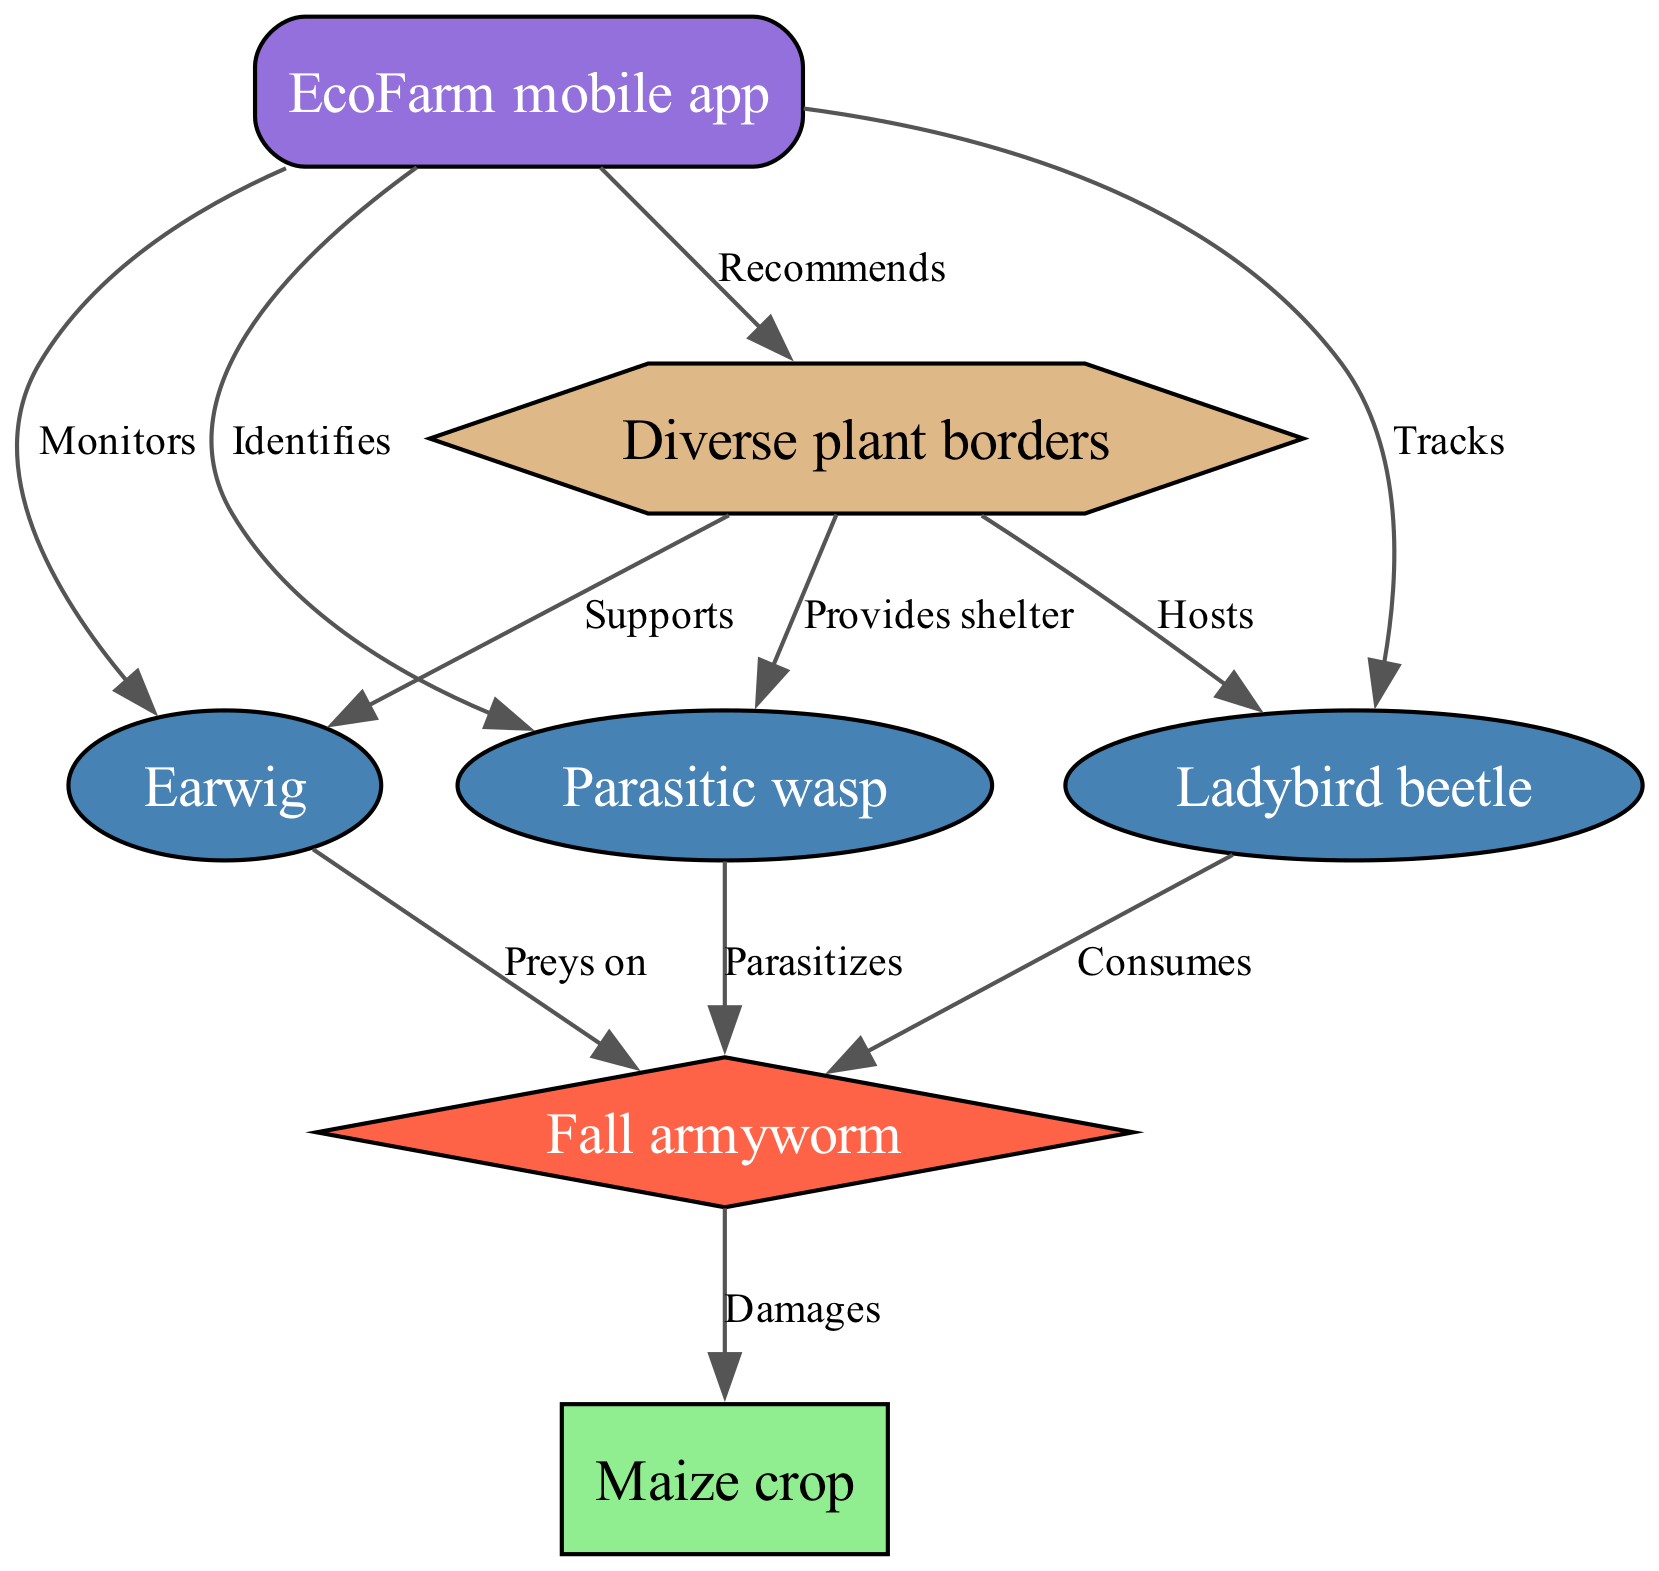What is the main crop shown in the diagram? The diagram specifically labels the main crop as "Maize crop." This information is presented in the nodes section, where each node has its unique label, and the crop is clearly marked.
Answer: Maize crop How many predators are represented in the diagram? By counting the nodes labeled as predators, we see "Earwig," "Ladybird beetle," and "Parasitic wasp," which totals to three distinct predators.
Answer: 3 What does the Earwig do to the Fall armyworm? The connection between "Earwig" and "Fall armyworm" is indicated with the label "Preys on," showing a direct predatory relationship from the Earwig towards the pest.
Answer: Preys on Which predator is supported by the Diverse plant borders? Looking at the edges connected to "Diverse plant borders," it is evident that "Earwig" is directly linked and noted with the label "Supports," indicating its reliance on this habitat.
Answer: Earwig What is the role of the EcoFarm mobile app in the ecosystem? The app establishes various connections with the predators, such as monitoring, tracking, and identifying them. This shows that its role is primarily focused on managing these predators in the agricultural ecosystem.
Answer: Manages predators Which organism does the Parasitic wasp affect? The diagram directly shows an arrow from "Parasitic wasp" to "Fall armyworm" with the label "Parasitizes." This indicates that the Parasitic wasp is aimed at affecting the Fall armyworm.
Answer: Fall armyworm What kind of habitat is providing support for the predators? From the diagram, "Diverse plant borders" is mentioned as a habitat that supports, hosts, and provides shelter for different predator species. This is specified in the node labeled "habitat."
Answer: Diverse plant borders Which species consumes the Fall armyworm? "Ladybird beetle" is connected with the label "Consumes" to the "Fall armyworm," which shows its role as a consumer of this pest in the food web.
Answer: Consumes 